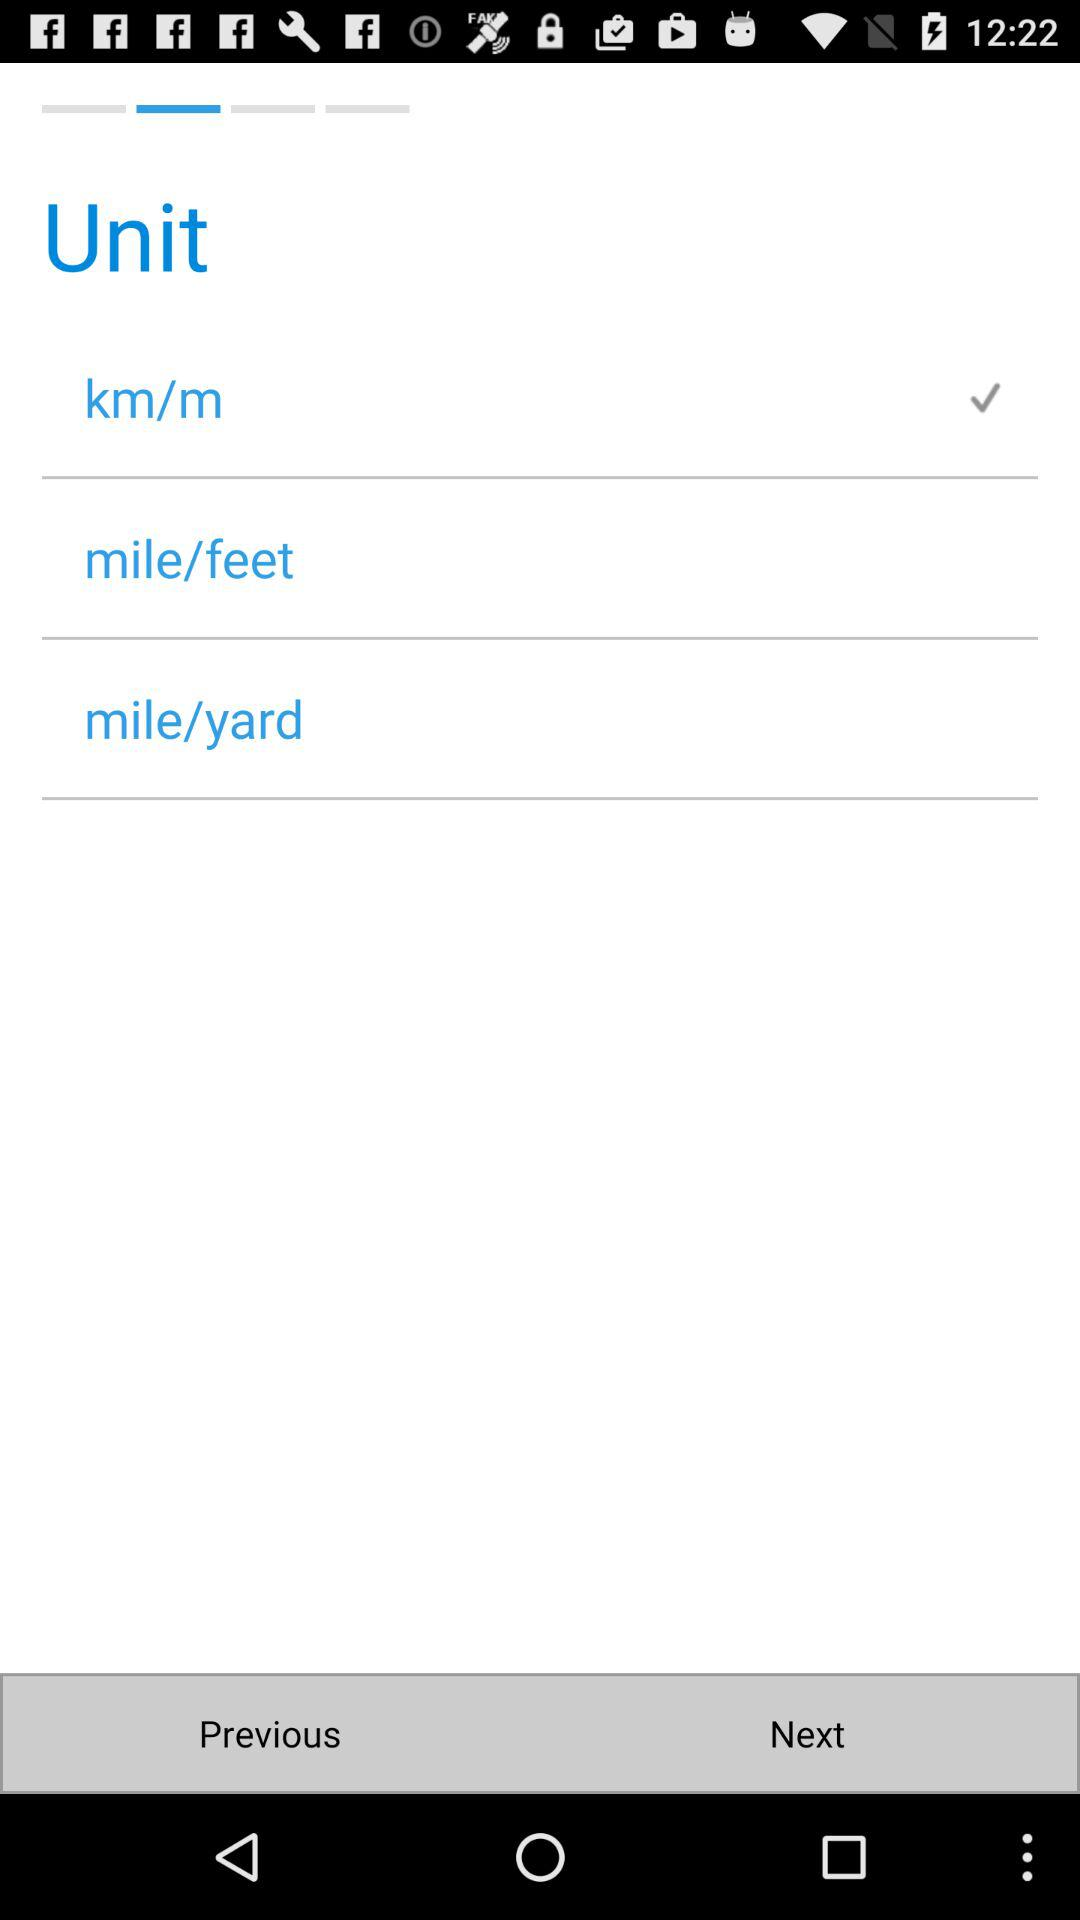How many units are checked?
Answer the question using a single word or phrase. 1 